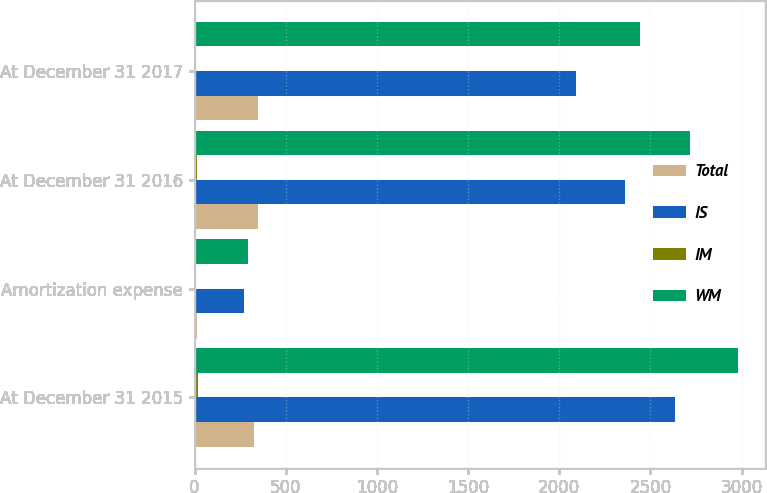Convert chart to OTSL. <chart><loc_0><loc_0><loc_500><loc_500><stacked_bar_chart><ecel><fcel>At December 31 2015<fcel>Amortization expense<fcel>At December 31 2016<fcel>At December 31 2017<nl><fcel>Total<fcel>327<fcel>11<fcel>346<fcel>349<nl><fcel>IS<fcel>2632<fcel>271<fcel>2361<fcel>2092<nl><fcel>IM<fcel>20<fcel>9<fcel>11<fcel>4<nl><fcel>WM<fcel>2979<fcel>291<fcel>2718<fcel>2445<nl></chart> 